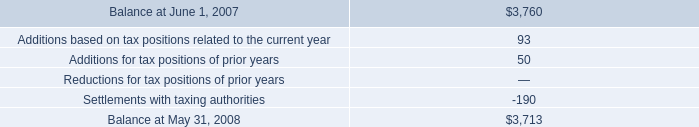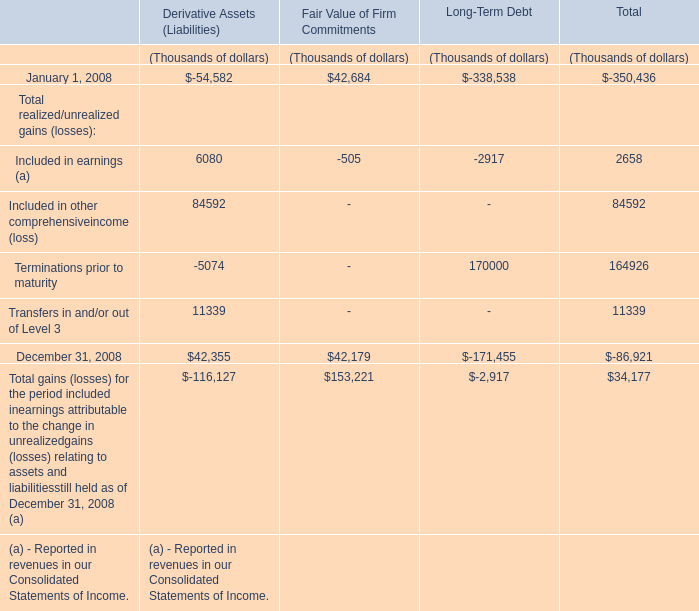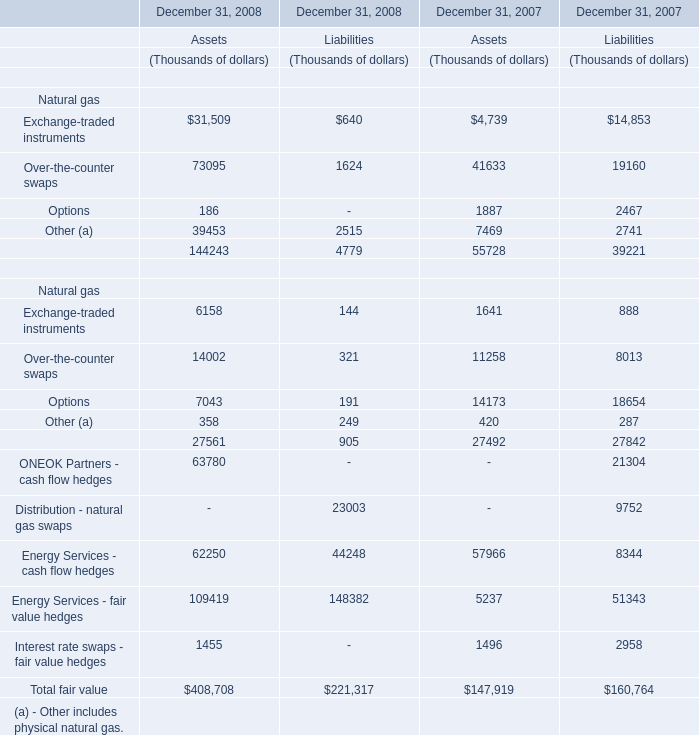Does the average value of Over-the-counter swaps in 2008 greater than that in 2007? 
Computations: ((73095 + 1624) - (41633 - 19160))
Answer: 52246.0. 